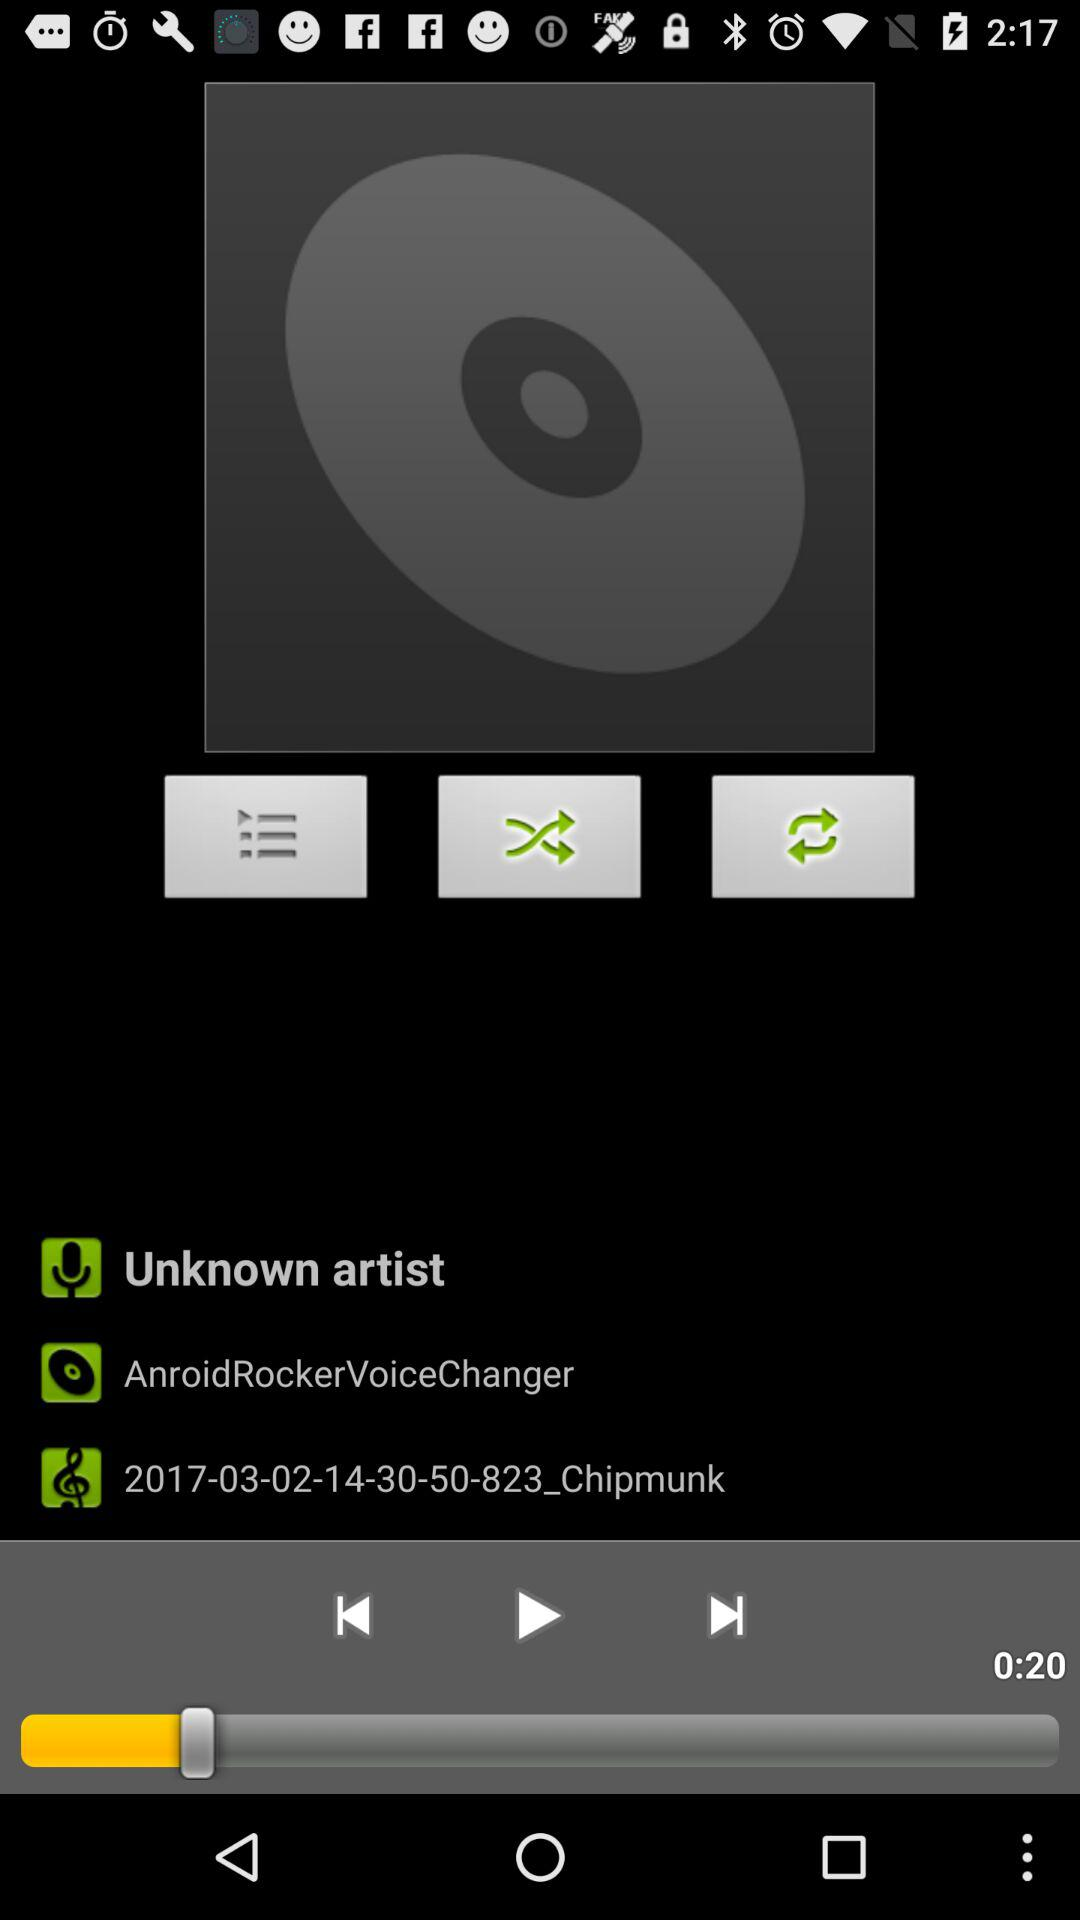How many songs will shuffle?
When the provided information is insufficient, respond with <no answer>. <no answer> 